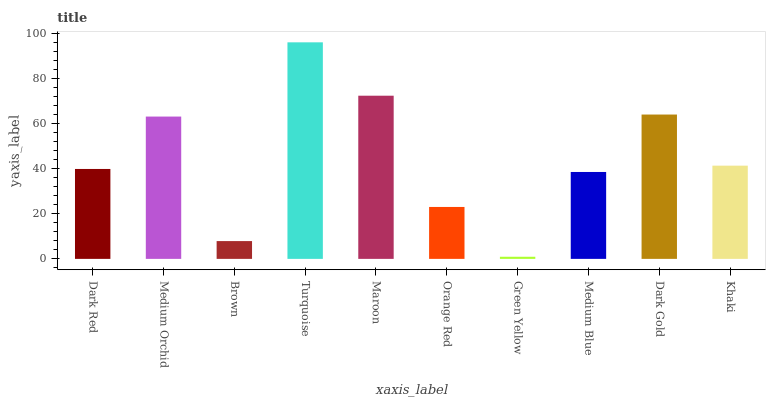Is Green Yellow the minimum?
Answer yes or no. Yes. Is Turquoise the maximum?
Answer yes or no. Yes. Is Medium Orchid the minimum?
Answer yes or no. No. Is Medium Orchid the maximum?
Answer yes or no. No. Is Medium Orchid greater than Dark Red?
Answer yes or no. Yes. Is Dark Red less than Medium Orchid?
Answer yes or no. Yes. Is Dark Red greater than Medium Orchid?
Answer yes or no. No. Is Medium Orchid less than Dark Red?
Answer yes or no. No. Is Khaki the high median?
Answer yes or no. Yes. Is Dark Red the low median?
Answer yes or no. Yes. Is Dark Gold the high median?
Answer yes or no. No. Is Brown the low median?
Answer yes or no. No. 